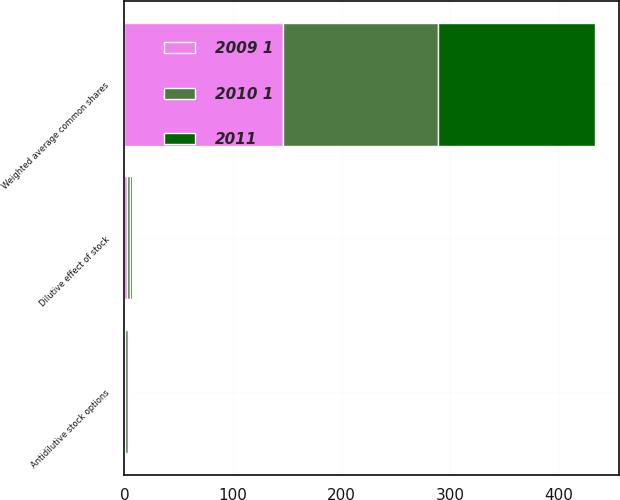<chart> <loc_0><loc_0><loc_500><loc_500><stacked_bar_chart><ecel><fcel>Weighted average common shares<fcel>Dilutive effect of stock<fcel>Antidilutive stock options<nl><fcel>2009 1<fcel>145.8<fcel>2.6<fcel>0.7<nl><fcel>2011<fcel>144.4<fcel>2.4<fcel>1.2<nl><fcel>2010 1<fcel>143<fcel>2.2<fcel>2.2<nl></chart> 